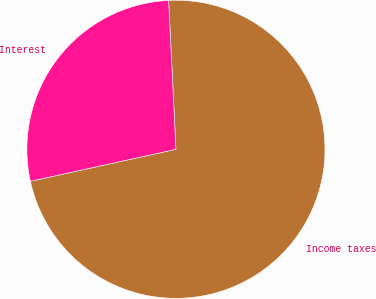<chart> <loc_0><loc_0><loc_500><loc_500><pie_chart><fcel>Income taxes<fcel>Interest<nl><fcel>72.34%<fcel>27.66%<nl></chart> 